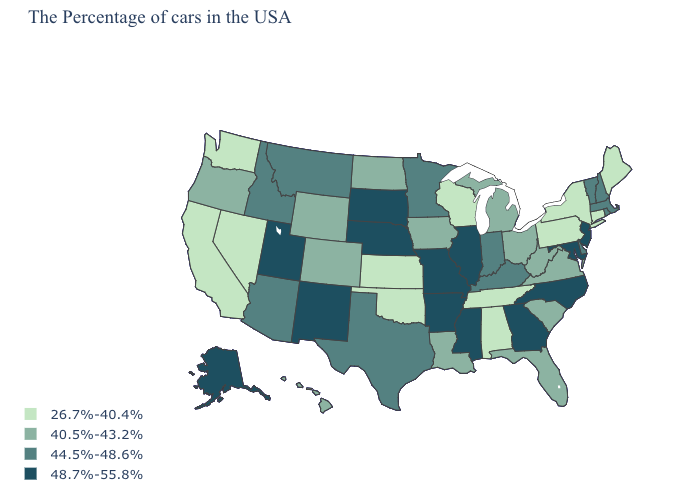Is the legend a continuous bar?
Answer briefly. No. Name the states that have a value in the range 40.5%-43.2%?
Give a very brief answer. Virginia, South Carolina, West Virginia, Ohio, Florida, Michigan, Louisiana, Iowa, North Dakota, Wyoming, Colorado, Oregon, Hawaii. Does South Dakota have the highest value in the MidWest?
Short answer required. Yes. What is the value of Wisconsin?
Concise answer only. 26.7%-40.4%. What is the highest value in the MidWest ?
Short answer required. 48.7%-55.8%. Does Michigan have a higher value than Alabama?
Give a very brief answer. Yes. What is the value of Indiana?
Write a very short answer. 44.5%-48.6%. How many symbols are there in the legend?
Write a very short answer. 4. What is the highest value in the Northeast ?
Give a very brief answer. 48.7%-55.8%. What is the value of Alabama?
Answer briefly. 26.7%-40.4%. What is the value of Ohio?
Keep it brief. 40.5%-43.2%. Which states hav the highest value in the South?
Answer briefly. Maryland, North Carolina, Georgia, Mississippi, Arkansas. What is the value of Maine?
Give a very brief answer. 26.7%-40.4%. What is the highest value in states that border Texas?
Give a very brief answer. 48.7%-55.8%. 